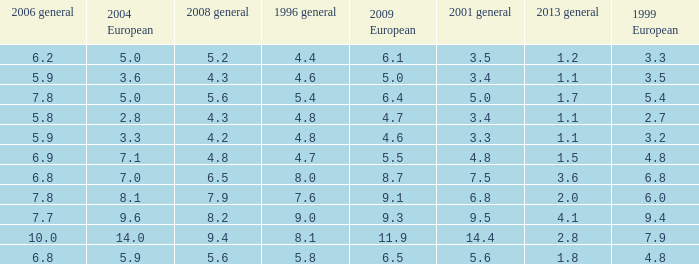What is the highest value for general 2008 when there is less than 5.5 in European 2009, more than 5.8 in general 2006, more than 3.3 in general 2001, and less than 3.6 for 2004 European? None. 